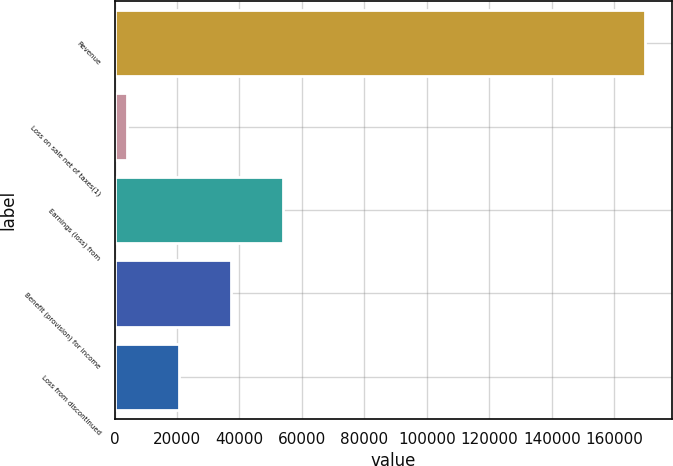Convert chart to OTSL. <chart><loc_0><loc_0><loc_500><loc_500><bar_chart><fcel>Revenue<fcel>Loss on sale net of taxes(1)<fcel>Earnings (loss) from<fcel>Benefit (provision) for income<fcel>Loss from discontinued<nl><fcel>169924<fcel>4086<fcel>53837.4<fcel>37253.6<fcel>20669.8<nl></chart> 